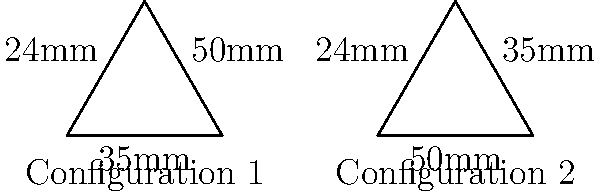In your latest camera lens comparison video, you're discussing two different lens configurations. Configuration 1 has lenses of 35mm, 50mm, and 24mm arranged clockwise, while Configuration 2 has lenses of 50mm, 35mm, and 24mm arranged clockwise. Are these two configurations congruent? Explain your reasoning. To determine if the two lens configurations are congruent, we need to follow these steps:

1. Recognize that the configurations are represented by triangles, where each side corresponds to a lens.

2. Recall the definition of congruent triangles: they have the same shape and size, with equal corresponding sides and angles.

3. Compare the side lengths (lens focal lengths) of both configurations:
   - Configuration 1: 35mm, 50mm, 24mm
   - Configuration 2: 50mm, 35mm, 24mm

4. Notice that both configurations have the same set of side lengths, just in a different order.

5. Consider the Side-Side-Side (SSS) congruence theorem: if three sides of one triangle are equal to three sides of another triangle, the triangles are congruent.

6. Apply the SSS theorem to our configurations: since both have sides of 35mm, 50mm, and 24mm, they satisfy the conditions for congruence.

7. Observe that the only difference between the configurations is the arrangement (order) of the lenses, which doesn't affect congruence.

Therefore, despite the different arrangement of lenses, the two configurations are congruent because they have the same set of side lengths, satisfying the SSS congruence theorem.
Answer: Yes, congruent (SSS theorem). 